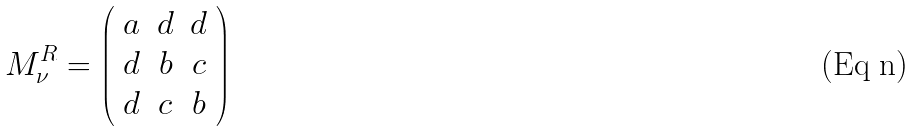<formula> <loc_0><loc_0><loc_500><loc_500>M _ { \nu } ^ { R } = \left ( \begin{array} { c c c } a & d & d \\ d & b & c \\ d & c & b \end{array} \right )</formula> 